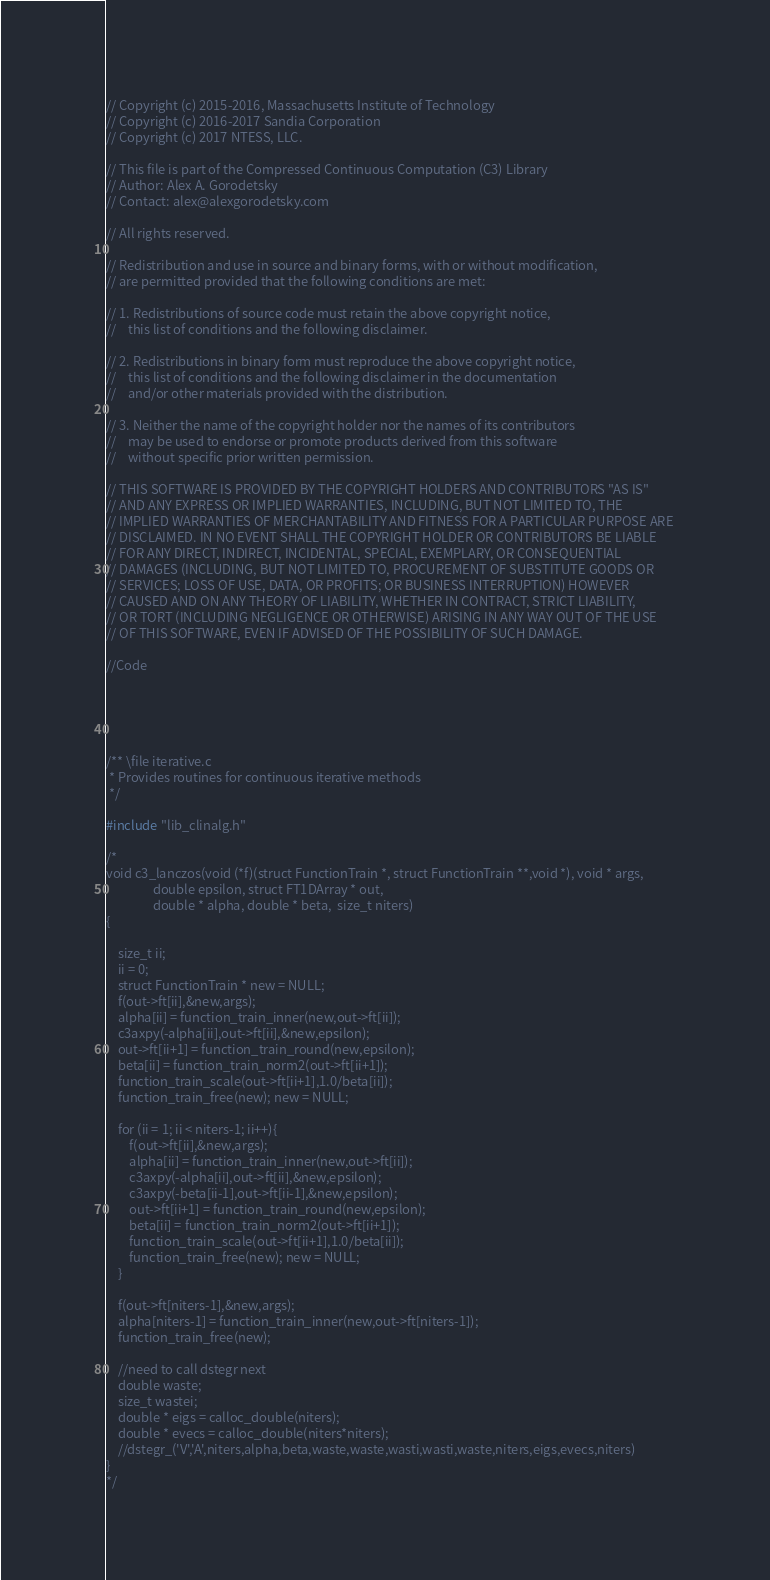Convert code to text. <code><loc_0><loc_0><loc_500><loc_500><_C_>// Copyright (c) 2015-2016, Massachusetts Institute of Technology
// Copyright (c) 2016-2017 Sandia Corporation
// Copyright (c) 2017 NTESS, LLC.

// This file is part of the Compressed Continuous Computation (C3) Library
// Author: Alex A. Gorodetsky 
// Contact: alex@alexgorodetsky.com

// All rights reserved.

// Redistribution and use in source and binary forms, with or without modification, 
// are permitted provided that the following conditions are met:

// 1. Redistributions of source code must retain the above copyright notice, 
//    this list of conditions and the following disclaimer.

// 2. Redistributions in binary form must reproduce the above copyright notice, 
//    this list of conditions and the following disclaimer in the documentation 
//    and/or other materials provided with the distribution.

// 3. Neither the name of the copyright holder nor the names of its contributors 
//    may be used to endorse or promote products derived from this software 
//    without specific prior written permission.

// THIS SOFTWARE IS PROVIDED BY THE COPYRIGHT HOLDERS AND CONTRIBUTORS "AS IS" 
// AND ANY EXPRESS OR IMPLIED WARRANTIES, INCLUDING, BUT NOT LIMITED TO, THE 
// IMPLIED WARRANTIES OF MERCHANTABILITY AND FITNESS FOR A PARTICULAR PURPOSE ARE 
// DISCLAIMED. IN NO EVENT SHALL THE COPYRIGHT HOLDER OR CONTRIBUTORS BE LIABLE 
// FOR ANY DIRECT, INDIRECT, INCIDENTAL, SPECIAL, EXEMPLARY, OR CONSEQUENTIAL 
// DAMAGES (INCLUDING, BUT NOT LIMITED TO, PROCUREMENT OF SUBSTITUTE GOODS OR 
// SERVICES; LOSS OF USE, DATA, OR PROFITS; OR BUSINESS INTERRUPTION) HOWEVER 
// CAUSED AND ON ANY THEORY OF LIABILITY, WHETHER IN CONTRACT, STRICT LIABILITY, 
// OR TORT (INCLUDING NEGLIGENCE OR OTHERWISE) ARISING IN ANY WAY OUT OF THE USE 
// OF THIS SOFTWARE, EVEN IF ADVISED OF THE POSSIBILITY OF SUCH DAMAGE.

//Code





/** \file iterative.c
 * Provides routines for continuous iterative methods
 */

#include "lib_clinalg.h"

/*
void c3_lanczos(void (*f)(struct FunctionTrain *, struct FunctionTrain **,void *), void * args,
                double epsilon, struct FT1DArray * out, 
                double * alpha, double * beta,  size_t niters)
{
    
    size_t ii;
    ii = 0;
    struct FunctionTrain * new = NULL;
    f(out->ft[ii],&new,args);
    alpha[ii] = function_train_inner(new,out->ft[ii]);
    c3axpy(-alpha[ii],out->ft[ii],&new,epsilon);
    out->ft[ii+1] = function_train_round(new,epsilon);
    beta[ii] = function_train_norm2(out->ft[ii+1]);
    function_train_scale(out->ft[ii+1],1.0/beta[ii]);
    function_train_free(new); new = NULL;
    
    for (ii = 1; ii < niters-1; ii++){
        f(out->ft[ii],&new,args);
        alpha[ii] = function_train_inner(new,out->ft[ii]);
        c3axpy(-alpha[ii],out->ft[ii],&new,epsilon);
        c3axpy(-beta[ii-1],out->ft[ii-1],&new,epsilon);
        out->ft[ii+1] = function_train_round(new,epsilon);
        beta[ii] = function_train_norm2(out->ft[ii+1]);
        function_train_scale(out->ft[ii+1],1.0/beta[ii]);
        function_train_free(new); new = NULL;
    }
    
    f(out->ft[niters-1],&new,args);
    alpha[niters-1] = function_train_inner(new,out->ft[niters-1]);
    function_train_free(new);
    
    //need to call dstegr next
    double waste;
    size_t wastei;
    double * eigs = calloc_double(niters);
    double * evecs = calloc_double(niters*niters);
    //dstegr_('V','A',niters,alpha,beta,waste,waste,wasti,wasti,waste,niters,eigs,evecs,niters)
}
*/



</code> 